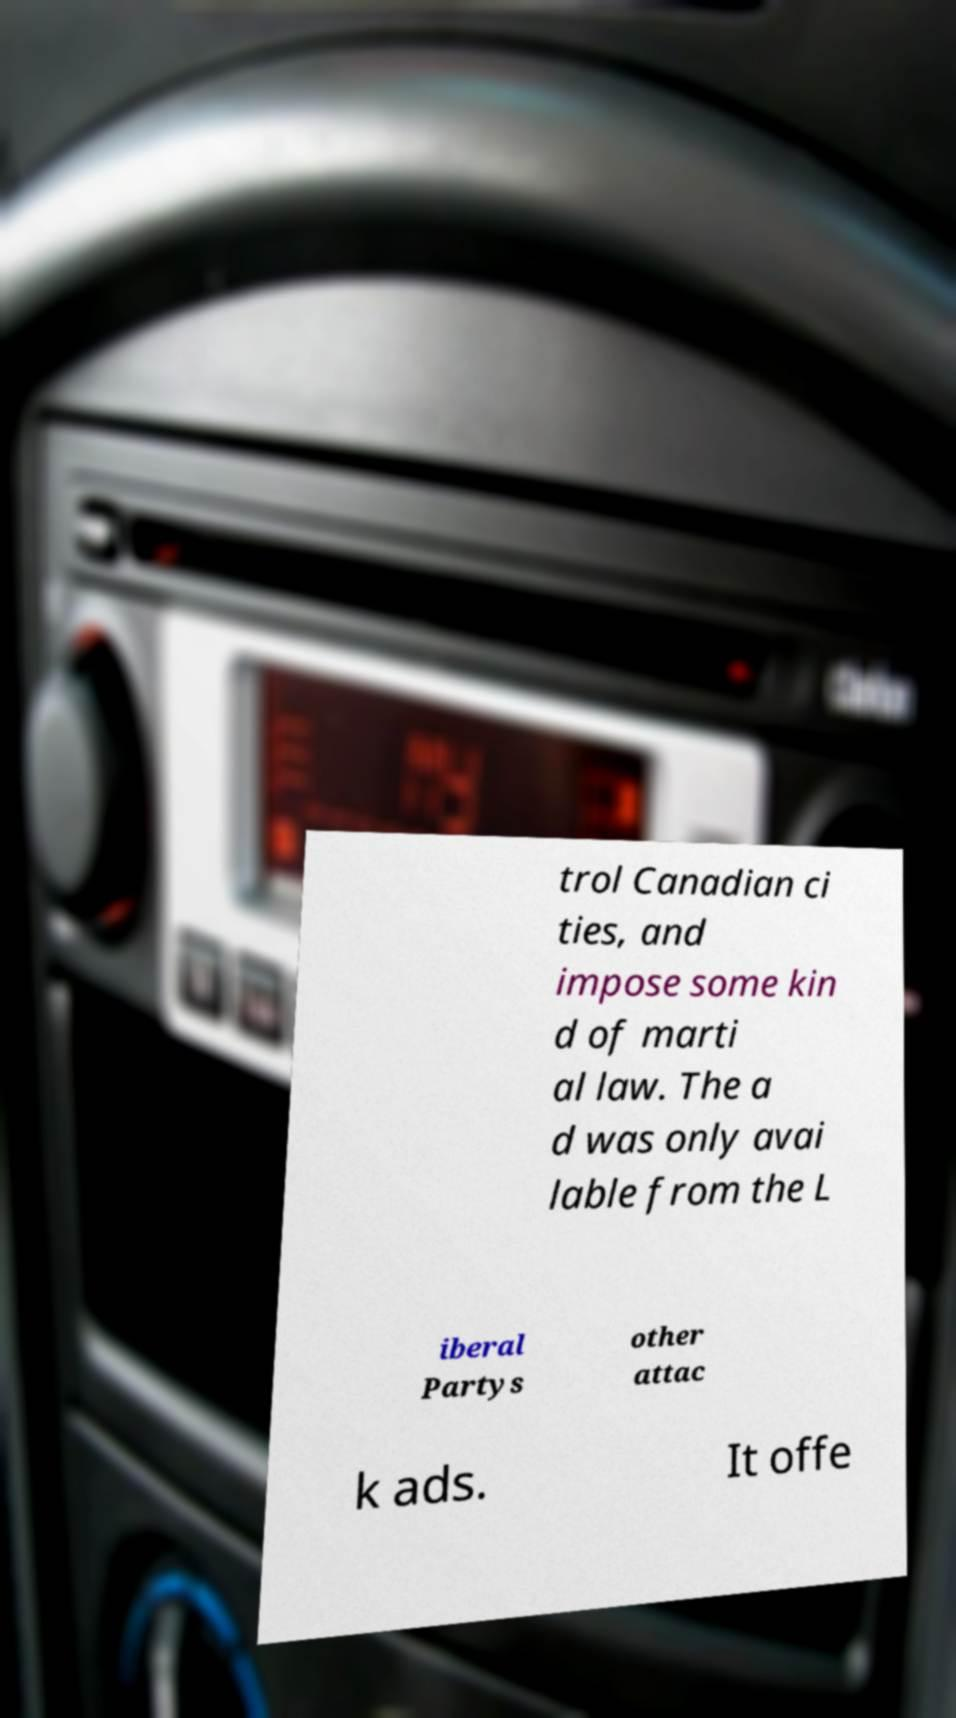Please read and relay the text visible in this image. What does it say? trol Canadian ci ties, and impose some kin d of marti al law. The a d was only avai lable from the L iberal Partys other attac k ads. It offe 